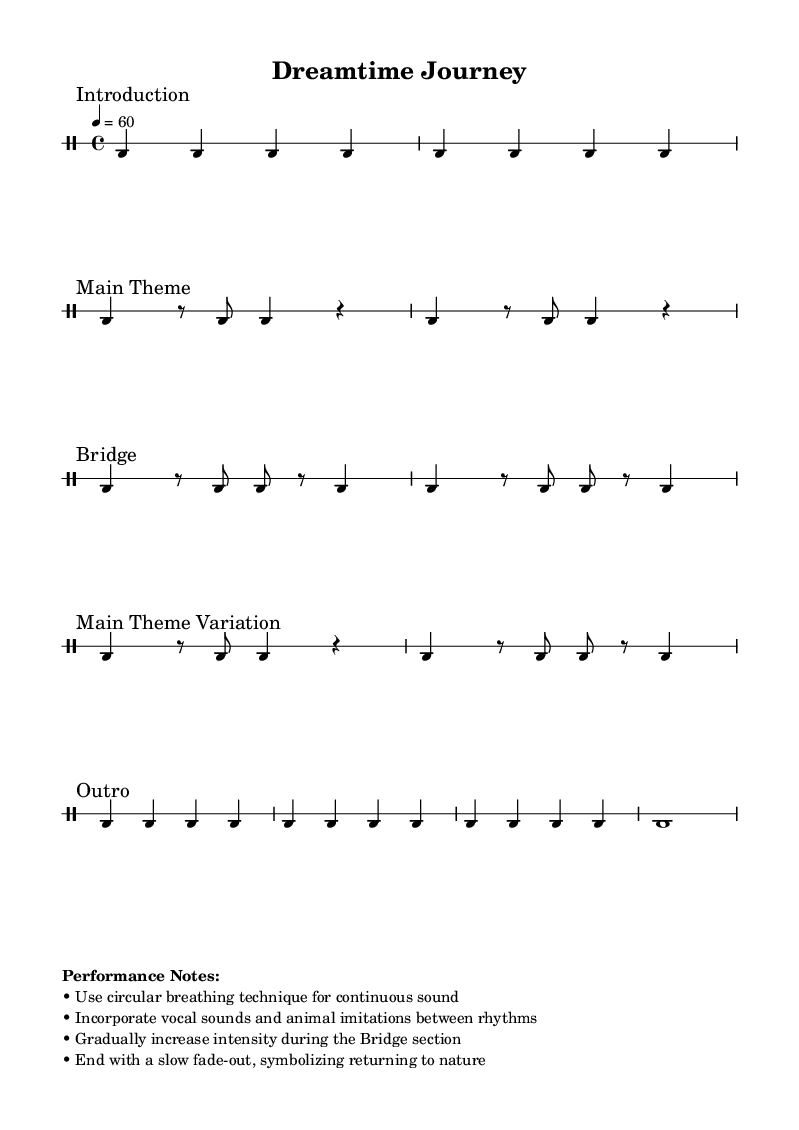What is the time signature of this music? The time signature is indicated at the beginning of the score as 4/4, meaning there are four beats in each measure.
Answer: 4/4 What is the tempo marking for this piece? The tempo marking is provided in the score as "4 = 60", denoting that there should be 60 beats per minute, which is a moderate pace.
Answer: 60 How many times is the drone pattern repeated in the introduction? The score specifies "repeat unfold 2" for the drone pattern in the introduction, indicating that it is played twice.
Answer: 2 What is the main theme section called in the score? The section of the score labeled as "Main Theme" identifies the portion where the nature call pattern is presented, which is integral to the piece.
Answer: Main Theme During which section should the intensity gradually increase? The instructions state to "gradually increase intensity during the Bridge section," where the spiritual pulse pattern is played, emphasizing the crescendo in this part of the piece.
Answer: Bridge What vocal techniques are suggested to incorporate with the rhythms? The performance notes advise incorporating "vocal sounds and animal imitations," indicating a connection to nature and enhancing the musical expression.
Answer: Vocal sounds and animal imitations 